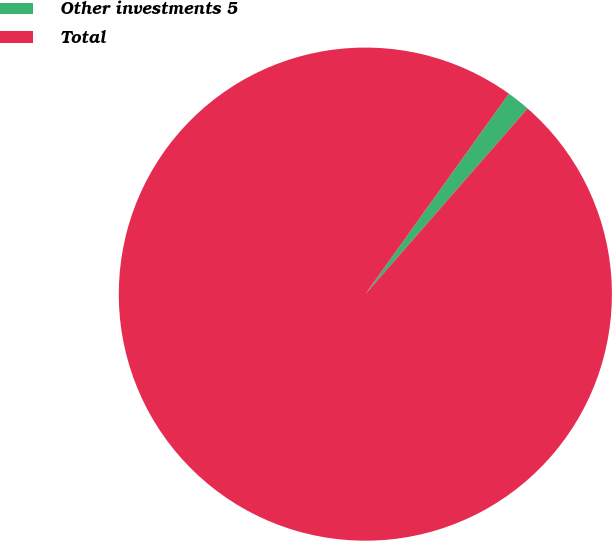Convert chart to OTSL. <chart><loc_0><loc_0><loc_500><loc_500><pie_chart><fcel>Other investments 5<fcel>Total<nl><fcel>1.54%<fcel>98.46%<nl></chart> 